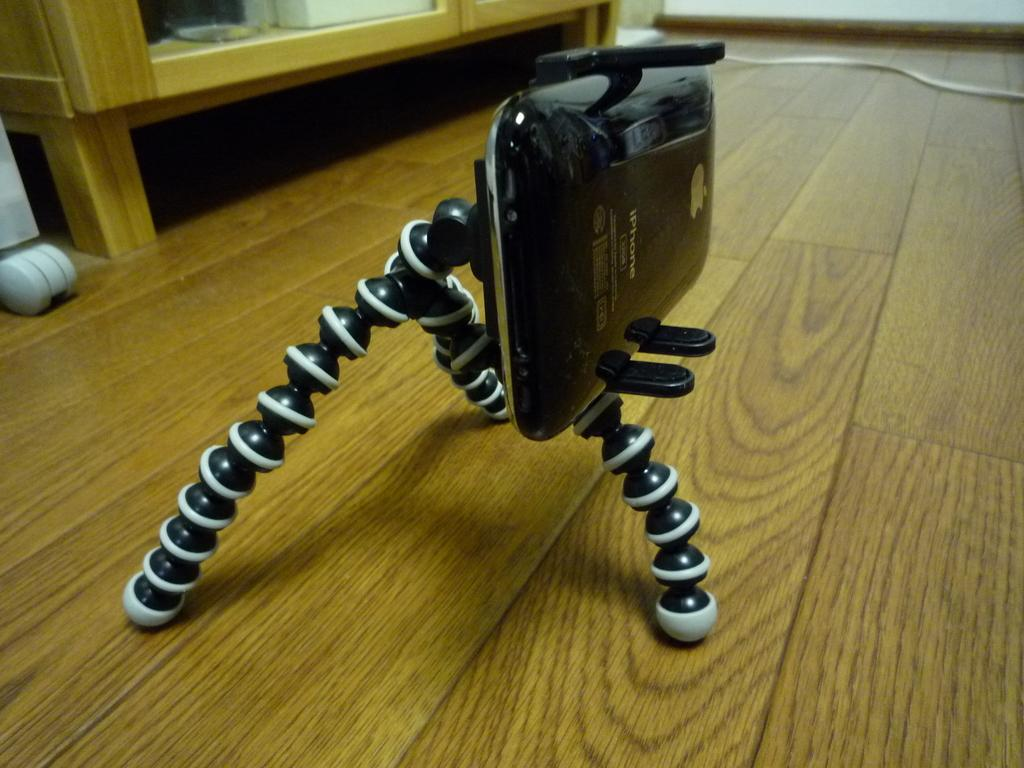What is the main object in the image? There is a black stand in the image. What is placed on the black stand? A mobile is present on the black stand. Can you describe another object in the image? There is a wooden object in the image. What else can be seen in the image? There is a cable in the image. Are there any other unspecified items in the image? Yes, there are other unspecified things in the image. What type of mailbox is attached to the wooden object in the image? There is no mailbox present in the image; it only features a black stand, a mobile, a wooden object, and a cable. 